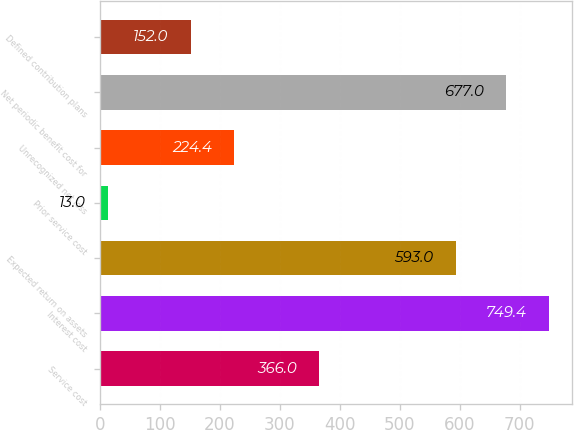<chart> <loc_0><loc_0><loc_500><loc_500><bar_chart><fcel>Service cost<fcel>Interest cost<fcel>Expected return on assets<fcel>Prior service cost<fcel>Unrecognized net loss<fcel>Net periodic benefit cost for<fcel>Defined contribution plans<nl><fcel>366<fcel>749.4<fcel>593<fcel>13<fcel>224.4<fcel>677<fcel>152<nl></chart> 